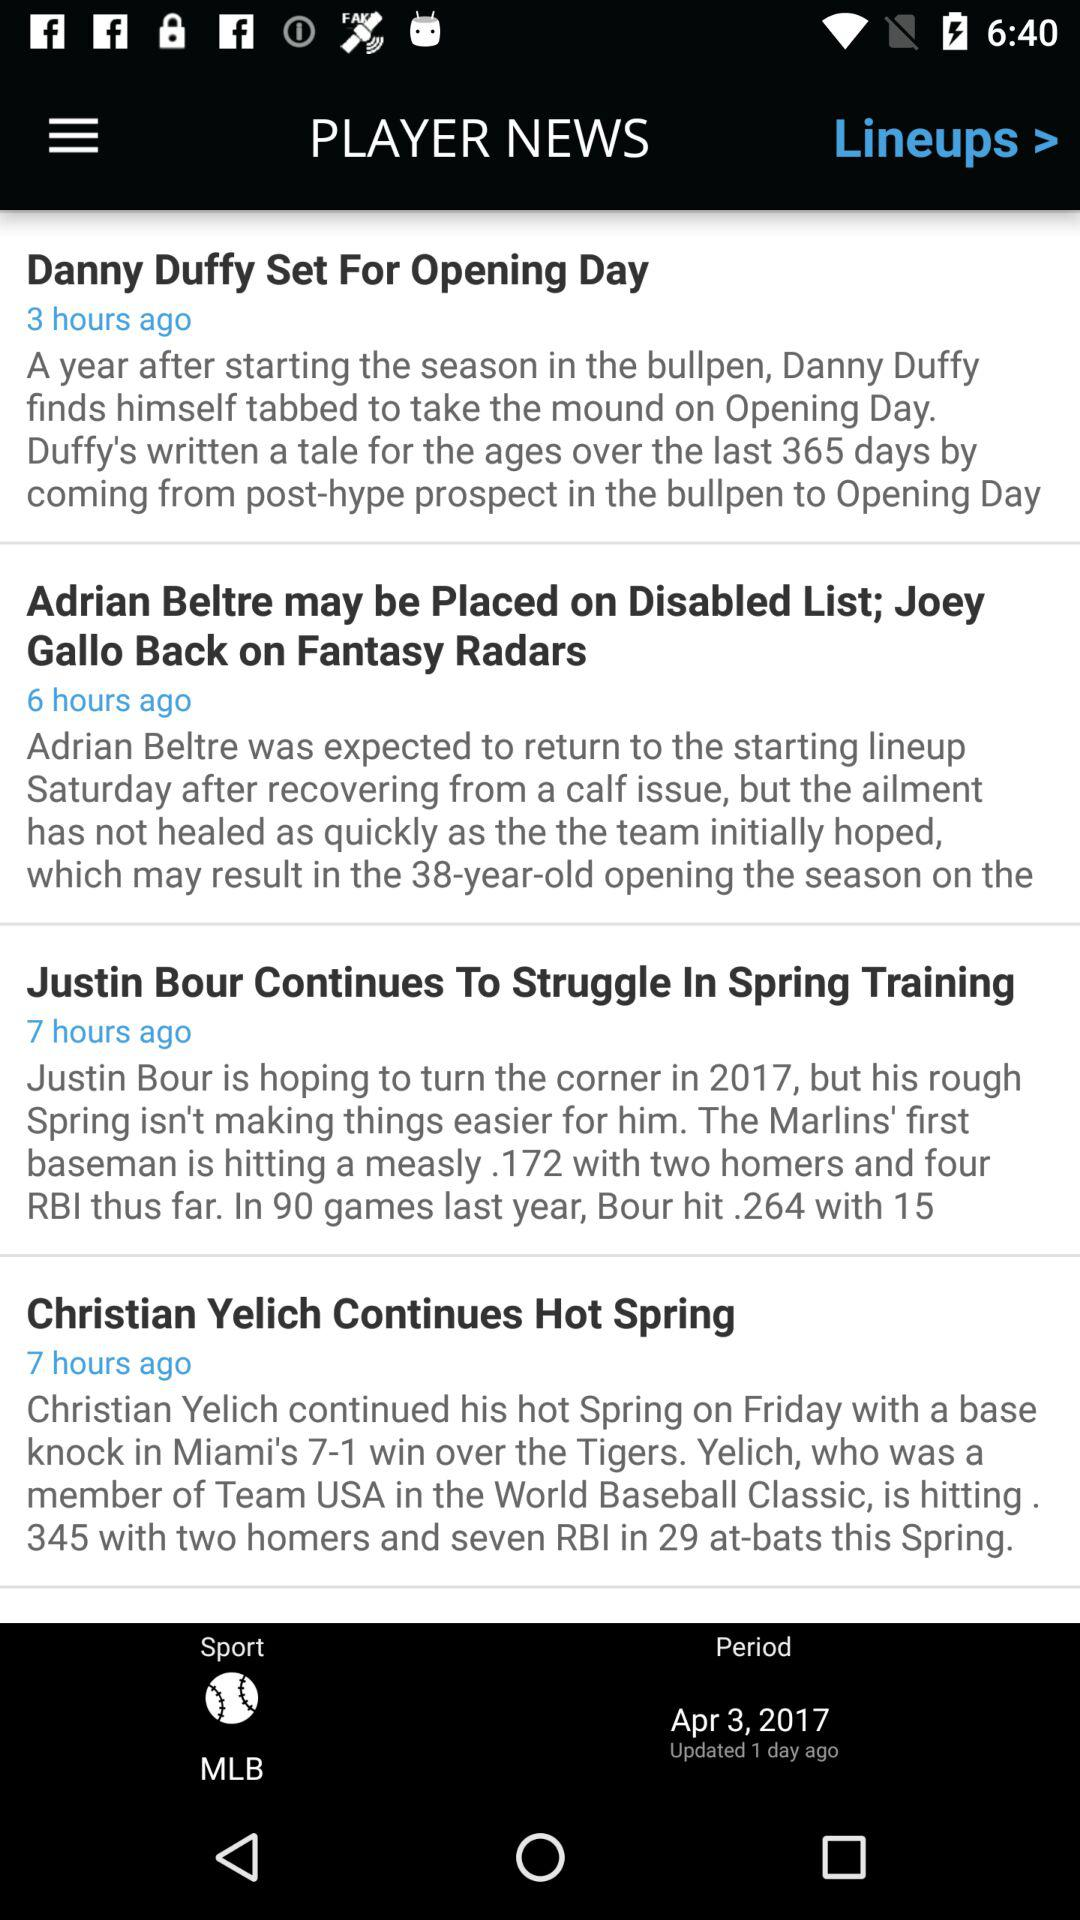When was the news "Danny Duffy Set For Opening Day" published? The news was published 3 hours ago. 